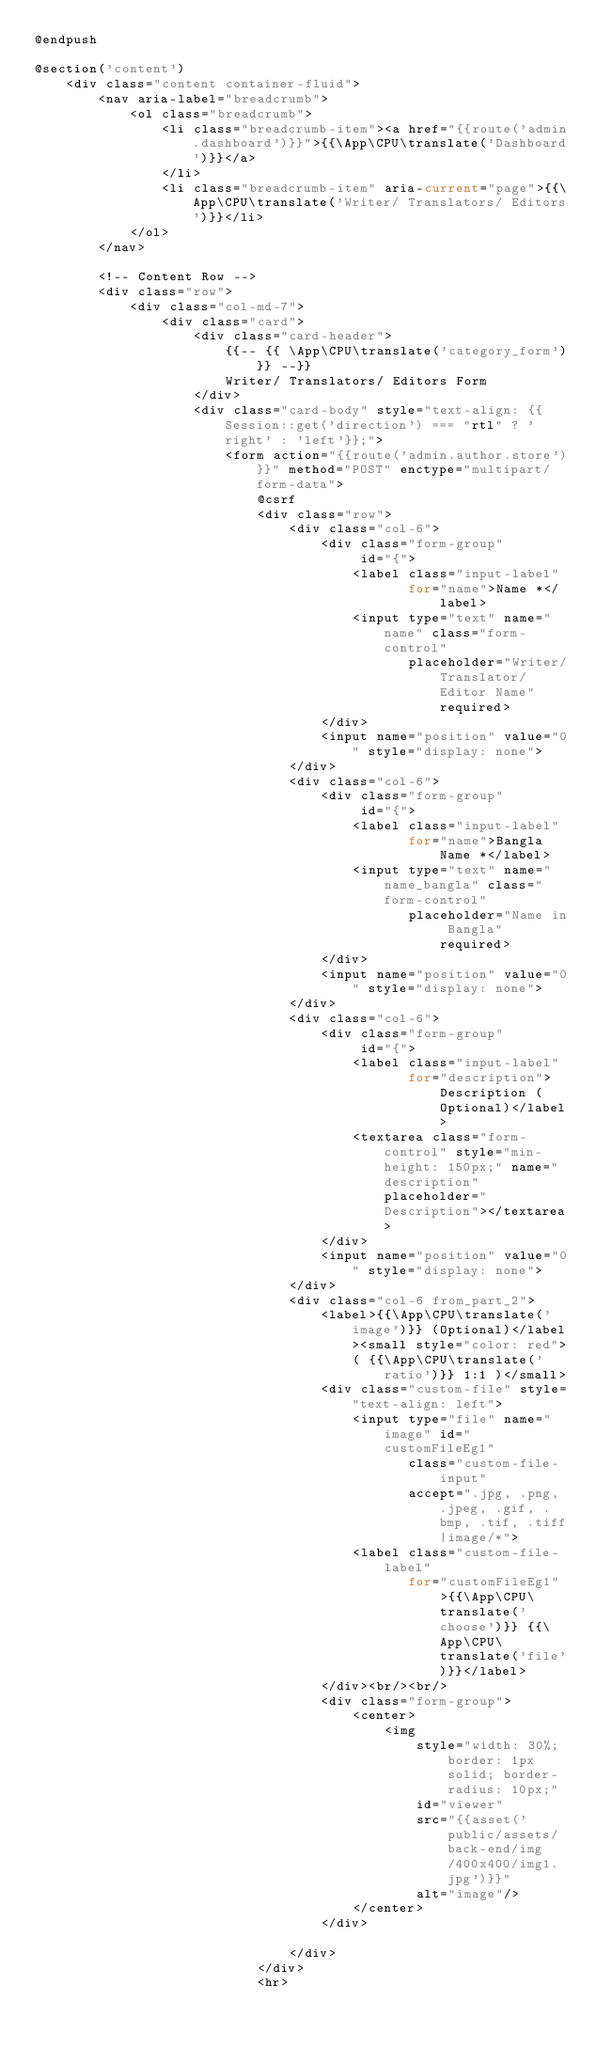<code> <loc_0><loc_0><loc_500><loc_500><_PHP_>@endpush

@section('content')
    <div class="content container-fluid">
        <nav aria-label="breadcrumb">
            <ol class="breadcrumb">
                <li class="breadcrumb-item"><a href="{{route('admin.dashboard')}}">{{\App\CPU\translate('Dashboard')}}</a>
                </li>
                <li class="breadcrumb-item" aria-current="page">{{\App\CPU\translate('Writer/ Translators/ Editors')}}</li>
            </ol>
        </nav>

        <!-- Content Row -->
        <div class="row">
            <div class="col-md-7">
                <div class="card">
                    <div class="card-header">
                        {{-- {{ \App\CPU\translate('category_form')}} --}}
                        Writer/ Translators/ Editors Form
                    </div>
                    <div class="card-body" style="text-align: {{Session::get('direction') === "rtl" ? 'right' : 'left'}};">
                        <form action="{{route('admin.author.store')}}" method="POST" enctype="multipart/form-data">
                            @csrf
                            <div class="row">
                                <div class="col-6">
                                    <div class="form-group"
                                         id="{">
                                        <label class="input-label"
                                               for="name">Name *</label>
                                        <input type="text" name="name" class="form-control"
                                               placeholder="Writer/Translator/Editor Name" required>
                                    </div>
                                    <input name="position" value="0" style="display: none">
                                </div>
                                <div class="col-6">
                                    <div class="form-group"
                                         id="{">
                                        <label class="input-label"
                                               for="name">Bangla Name *</label>
                                        <input type="text" name="name_bangla" class="form-control"
                                               placeholder="Name in Bangla" required>
                                    </div>
                                    <input name="position" value="0" style="display: none">
                                </div>
                                <div class="col-6">
                                    <div class="form-group"
                                         id="{">
                                        <label class="input-label"
                                               for="description">Description (Optional)</label>
                                        <textarea class="form-control" style="min-height: 150px;" name="description" placeholder="Description"></textarea>
                                    </div>
                                    <input name="position" value="0" style="display: none">
                                </div>
                                <div class="col-6 from_part_2">
                                    <label>{{\App\CPU\translate('image')}} (Optional)</label><small style="color: red">
                                        ( {{\App\CPU\translate('ratio')}} 1:1 )</small>
                                    <div class="custom-file" style="text-align: left">
                                        <input type="file" name="image" id="customFileEg1"
                                               class="custom-file-input"
                                               accept=".jpg, .png, .jpeg, .gif, .bmp, .tif, .tiff|image/*">
                                        <label class="custom-file-label"
                                               for="customFileEg1">{{\App\CPU\translate('choose')}} {{\App\CPU\translate('file')}}</label>
                                    </div><br/><br/>
                                    <div class="form-group">
                                        <center>
                                            <img
                                                style="width: 30%;border: 1px solid; border-radius: 10px;"
                                                id="viewer"
                                                src="{{asset('public/assets/back-end/img/400x400/img1.jpg')}}"
                                                alt="image"/>
                                        </center>
                                    </div>

                                </div>
                            </div>
                            <hr></code> 